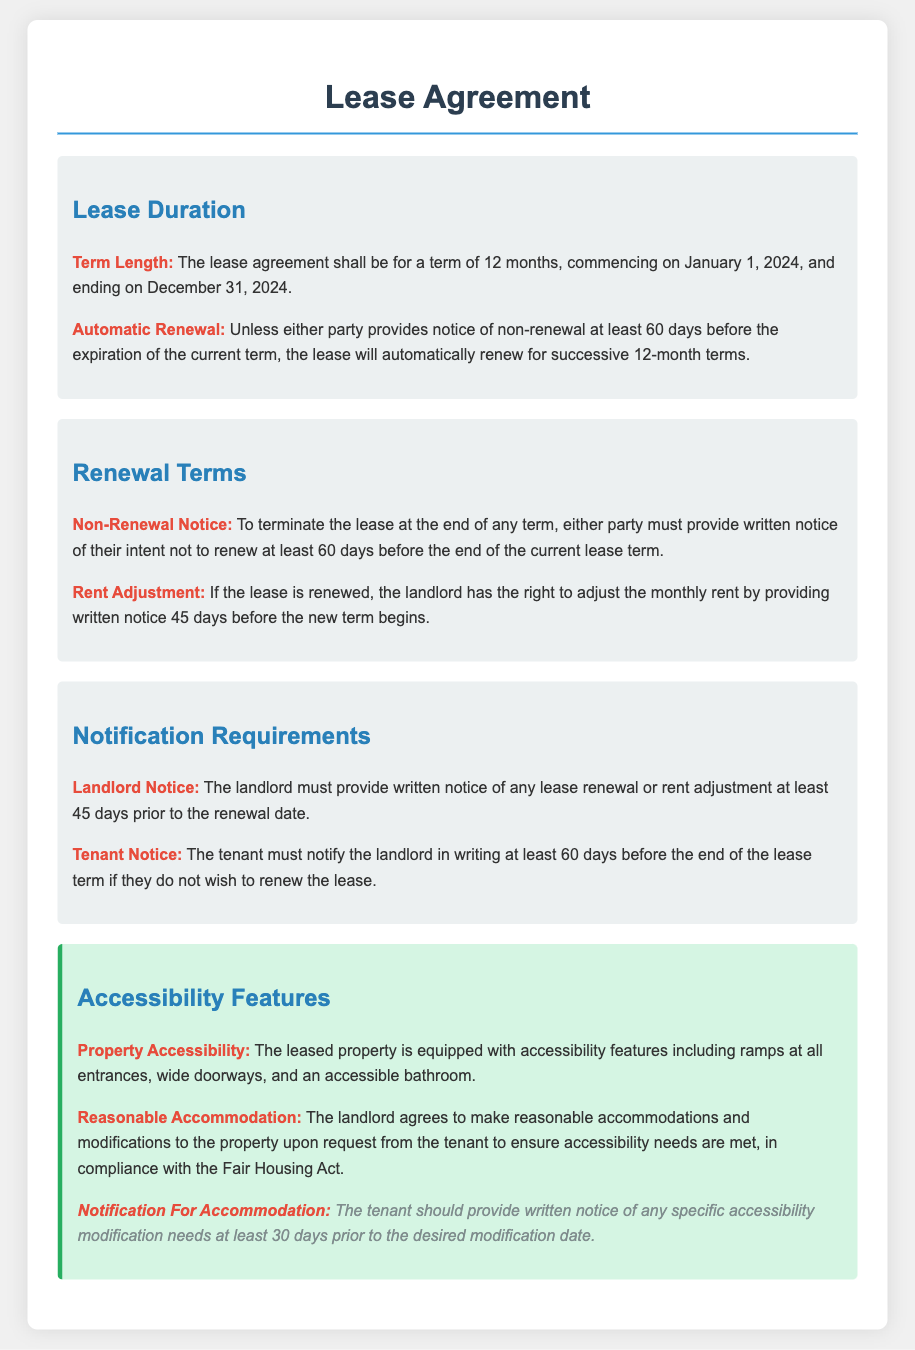What is the lease duration? The lease duration is specified in the document, stating it will last for a term of 12 months.
Answer: 12 months When does the lease commence? The document indicates the starting date of the lease agreement.
Answer: January 1, 2024 What is required for non-renewal notice? The document specifies the notice period needed for either party to notify their intent not to renew the lease.
Answer: 60 days What is the notice period for rent adjustment? The landlord must notify the tenant about a rent adjustment before a specific time mentioned in the document.
Answer: 45 days What features does the leased property have for accessibility? The document lists specific features that accommodate accessibility needs in the property.
Answer: Ramps at all entrances What is the maximum time to notify for accommodation requests? The document mentions a specific time frame in which the tenant must notify the landlord for modifications.
Answer: 30 days How long will the lease automatically renew for? The lease renewal terms are clearly mentioned in the document.
Answer: 12 months What must the landlord provide for a lease renewal? The documentation states what the landlord is responsible for when renewing the lease.
Answer: Written notice What happens if no notice is given before the lease term ends? The agreement explains the consequence of not providing notice regarding the renewal.
Answer: Automatic renewal 